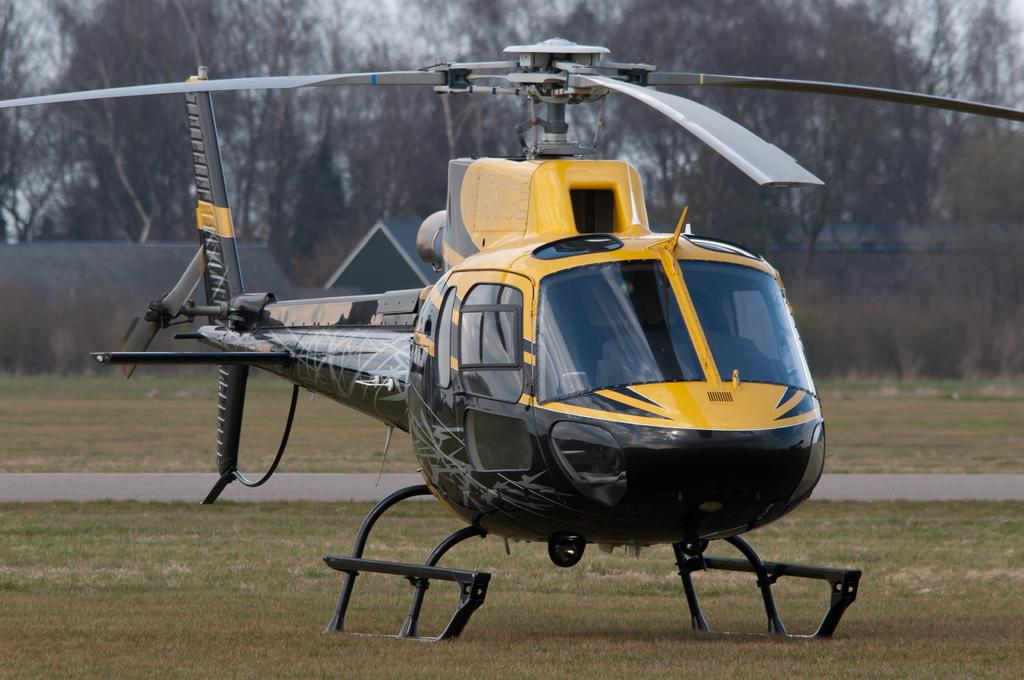What is the main subject of the image? The main subject of the image is a helicopter. What is the helicopter doing in the image? The helicopter is standing on the ground in the image. What type of surface is the helicopter standing on? The ground is covered with grass in the image. What color is the cap on the chicken in the image? There is no chicken or cap present in the image; it features a helicopter standing on grass-covered ground. 